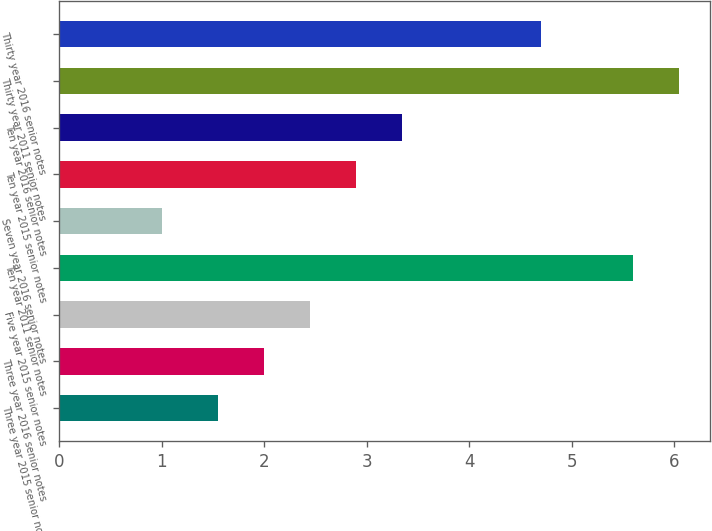<chart> <loc_0><loc_0><loc_500><loc_500><bar_chart><fcel>Three year 2015 senior notes<fcel>Three year 2016 senior notes<fcel>Five year 2015 senior notes<fcel>Ten year 2011 senior notes<fcel>Seven year 2016 senior notes<fcel>Ten year 2015 senior notes<fcel>Ten year 2016 senior notes<fcel>Thirty year 2011 senior notes<fcel>Thirty year 2016 senior notes<nl><fcel>1.55<fcel>2<fcel>2.45<fcel>5.6<fcel>1<fcel>2.9<fcel>3.35<fcel>6.05<fcel>4.7<nl></chart> 